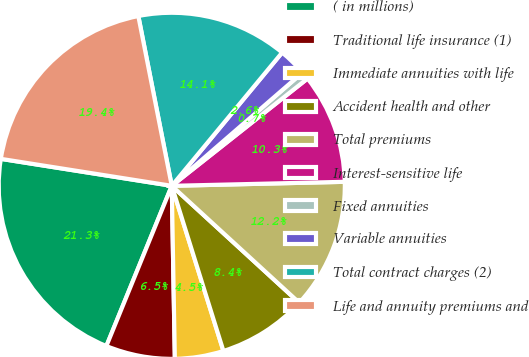<chart> <loc_0><loc_0><loc_500><loc_500><pie_chart><fcel>( in millions)<fcel>Traditional life insurance (1)<fcel>Immediate annuities with life<fcel>Accident health and other<fcel>Total premiums<fcel>Interest-sensitive life<fcel>Fixed annuities<fcel>Variable annuities<fcel>Total contract charges (2)<fcel>Life and annuity premiums and<nl><fcel>21.32%<fcel>6.45%<fcel>4.54%<fcel>8.36%<fcel>12.18%<fcel>10.27%<fcel>0.72%<fcel>2.63%<fcel>14.1%<fcel>19.41%<nl></chart> 